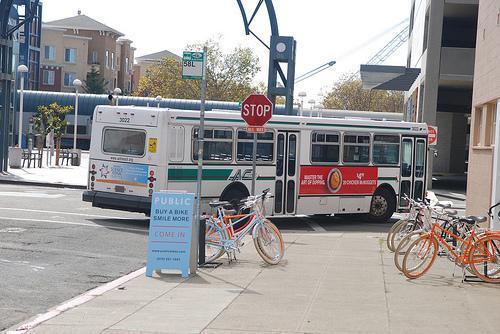How many busses are there?
Give a very brief answer. 1. How many of the street signs are octagon?
Give a very brief answer. 1. How many bikes are parked next to the curb?
Give a very brief answer. 3. 